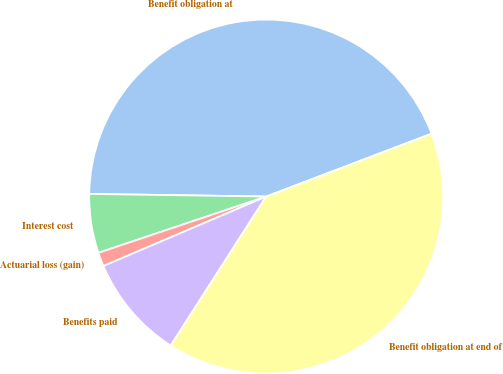<chart> <loc_0><loc_0><loc_500><loc_500><pie_chart><fcel>Benefit obligation at<fcel>Interest cost<fcel>Actuarial loss (gain)<fcel>Benefits paid<fcel>Benefit obligation at end of<nl><fcel>43.98%<fcel>5.39%<fcel>1.27%<fcel>9.51%<fcel>39.85%<nl></chart> 